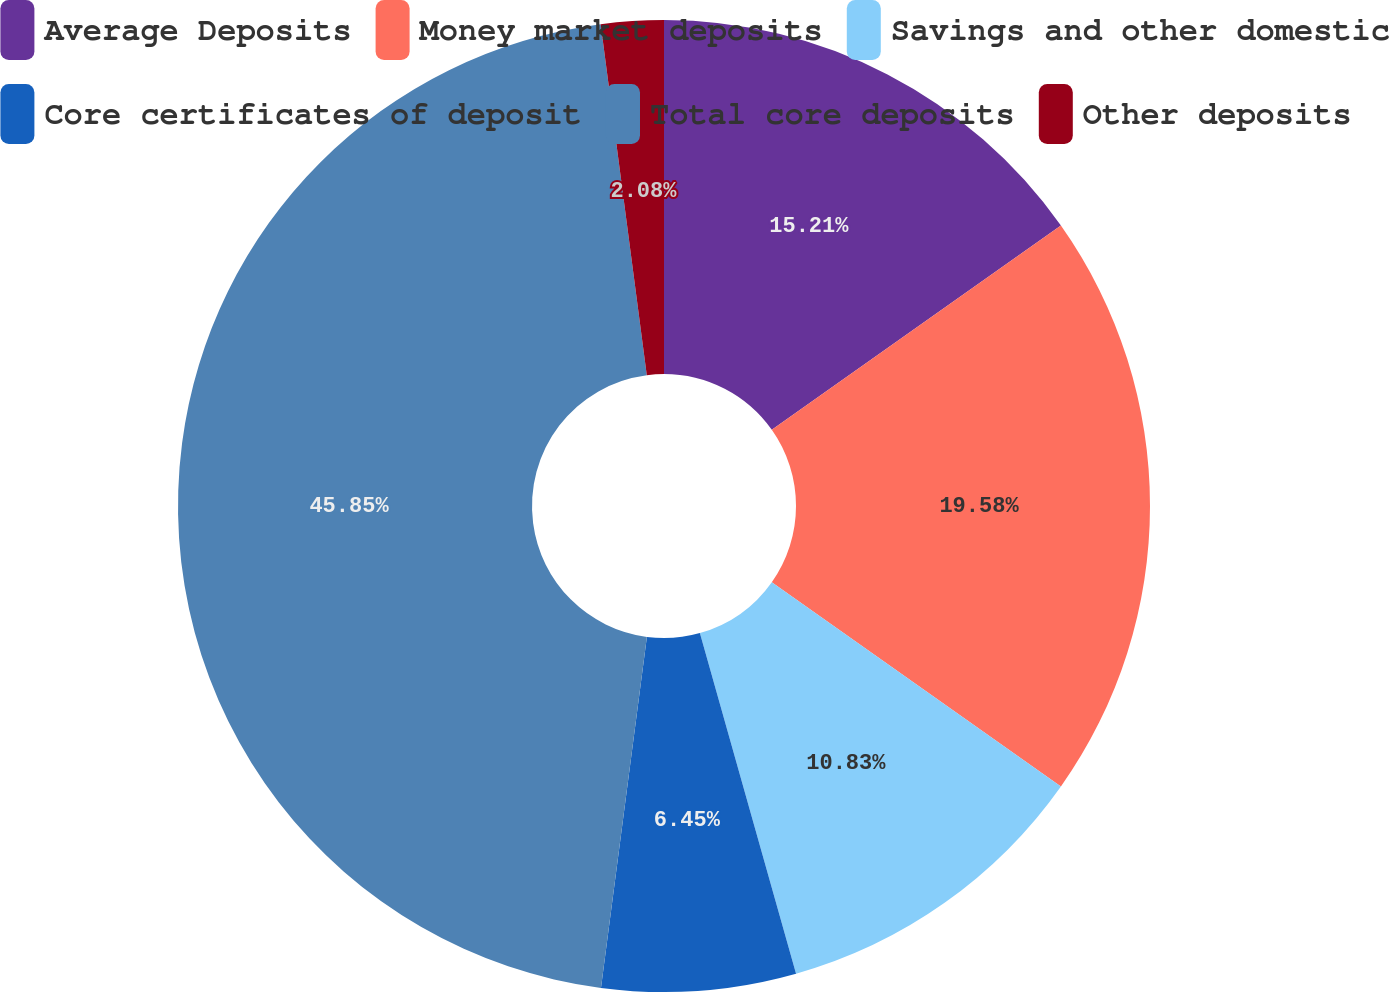Convert chart to OTSL. <chart><loc_0><loc_0><loc_500><loc_500><pie_chart><fcel>Average Deposits<fcel>Money market deposits<fcel>Savings and other domestic<fcel>Core certificates of deposit<fcel>Total core deposits<fcel>Other deposits<nl><fcel>15.21%<fcel>19.58%<fcel>10.83%<fcel>6.45%<fcel>45.85%<fcel>2.08%<nl></chart> 